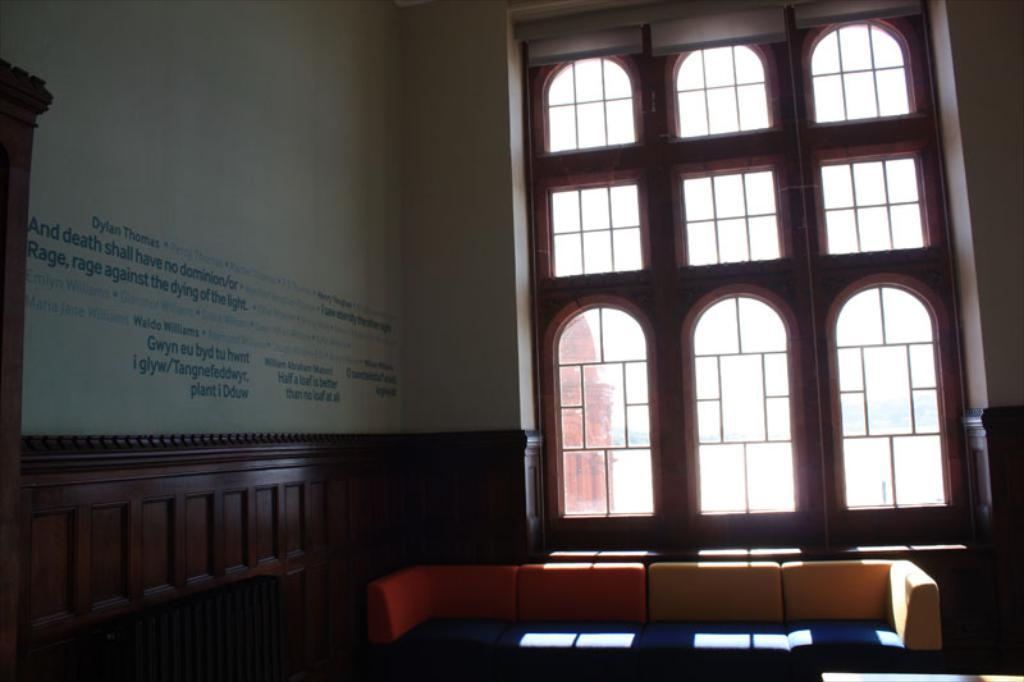What part of a building is visible in the image? The image shows the inner part of a building. What type of furniture is present inside the building? There is a couch inside the building. Is there any source of natural light visible in the image? Yes, there is a window inside the building. What can be seen on one of the walls inside the building? There is text written on a wall inside the building. What type of protest is taking place outside the building in the image? There is no protest visible in the image; it only shows the inner part of a building. How is the distribution of resources being managed inside the building? The image does not provide any information about the distribution of resources inside the building. 